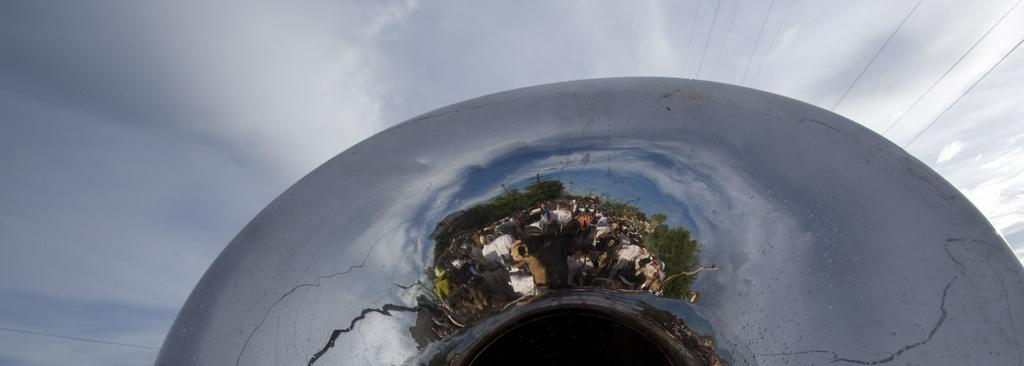What is the main subject of the image? The image appears to depict a cloud gate sculpture. What can be observed on the surface of the sculpture? There is a reflection visible on the sculpture. What is visible in the sky above the sculpture? Clouds are present in the sky. How many babies are laughing at the joke in the image? There are no babies or jokes present in the image; it features a cloud gate sculpture with a reflection and clouds in the sky. 